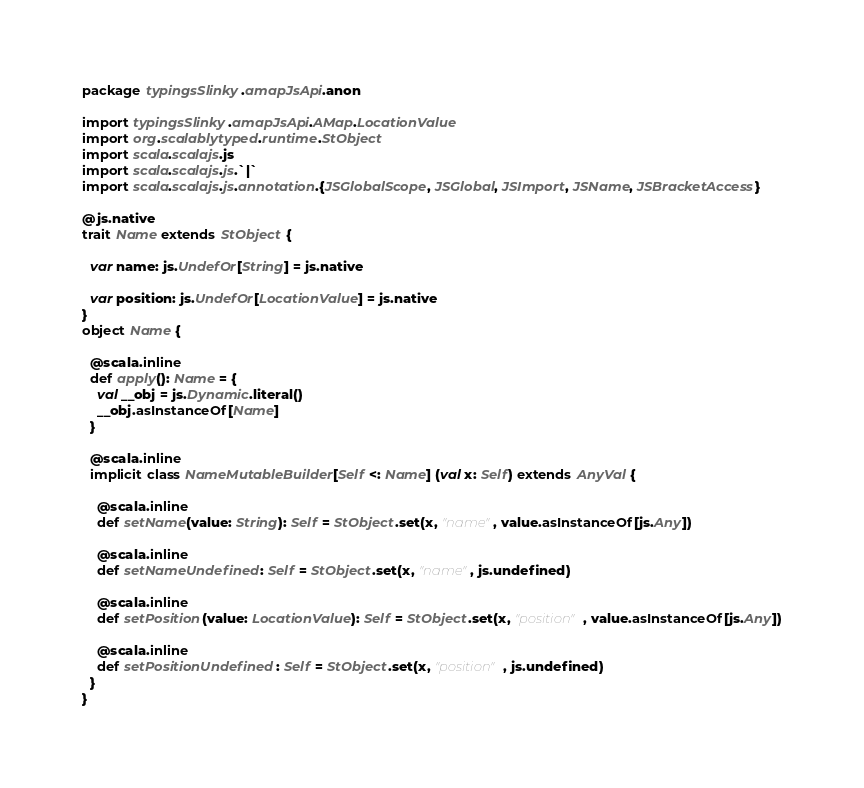Convert code to text. <code><loc_0><loc_0><loc_500><loc_500><_Scala_>package typingsSlinky.amapJsApi.anon

import typingsSlinky.amapJsApi.AMap.LocationValue
import org.scalablytyped.runtime.StObject
import scala.scalajs.js
import scala.scalajs.js.`|`
import scala.scalajs.js.annotation.{JSGlobalScope, JSGlobal, JSImport, JSName, JSBracketAccess}

@js.native
trait Name extends StObject {
  
  var name: js.UndefOr[String] = js.native
  
  var position: js.UndefOr[LocationValue] = js.native
}
object Name {
  
  @scala.inline
  def apply(): Name = {
    val __obj = js.Dynamic.literal()
    __obj.asInstanceOf[Name]
  }
  
  @scala.inline
  implicit class NameMutableBuilder[Self <: Name] (val x: Self) extends AnyVal {
    
    @scala.inline
    def setName(value: String): Self = StObject.set(x, "name", value.asInstanceOf[js.Any])
    
    @scala.inline
    def setNameUndefined: Self = StObject.set(x, "name", js.undefined)
    
    @scala.inline
    def setPosition(value: LocationValue): Self = StObject.set(x, "position", value.asInstanceOf[js.Any])
    
    @scala.inline
    def setPositionUndefined: Self = StObject.set(x, "position", js.undefined)
  }
}
</code> 